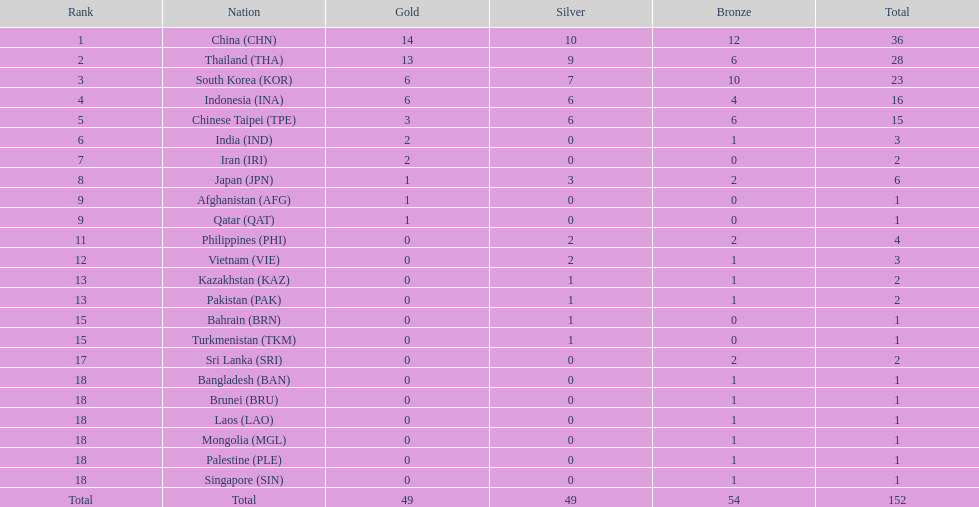Could you parse the entire table? {'header': ['Rank', 'Nation', 'Gold', 'Silver', 'Bronze', 'Total'], 'rows': [['1', 'China\xa0(CHN)', '14', '10', '12', '36'], ['2', 'Thailand\xa0(THA)', '13', '9', '6', '28'], ['3', 'South Korea\xa0(KOR)', '6', '7', '10', '23'], ['4', 'Indonesia\xa0(INA)', '6', '6', '4', '16'], ['5', 'Chinese Taipei\xa0(TPE)', '3', '6', '6', '15'], ['6', 'India\xa0(IND)', '2', '0', '1', '3'], ['7', 'Iran\xa0(IRI)', '2', '0', '0', '2'], ['8', 'Japan\xa0(JPN)', '1', '3', '2', '6'], ['9', 'Afghanistan\xa0(AFG)', '1', '0', '0', '1'], ['9', 'Qatar\xa0(QAT)', '1', '0', '0', '1'], ['11', 'Philippines\xa0(PHI)', '0', '2', '2', '4'], ['12', 'Vietnam\xa0(VIE)', '0', '2', '1', '3'], ['13', 'Kazakhstan\xa0(KAZ)', '0', '1', '1', '2'], ['13', 'Pakistan\xa0(PAK)', '0', '1', '1', '2'], ['15', 'Bahrain\xa0(BRN)', '0', '1', '0', '1'], ['15', 'Turkmenistan\xa0(TKM)', '0', '1', '0', '1'], ['17', 'Sri Lanka\xa0(SRI)', '0', '0', '2', '2'], ['18', 'Bangladesh\xa0(BAN)', '0', '0', '1', '1'], ['18', 'Brunei\xa0(BRU)', '0', '0', '1', '1'], ['18', 'Laos\xa0(LAO)', '0', '0', '1', '1'], ['18', 'Mongolia\xa0(MGL)', '0', '0', '1', '1'], ['18', 'Palestine\xa0(PLE)', '0', '0', '1', '1'], ['18', 'Singapore\xa0(SIN)', '0', '0', '1', '1'], ['Total', 'Total', '49', '49', '54', '152']]} How many total gold medal have been given? 49. 